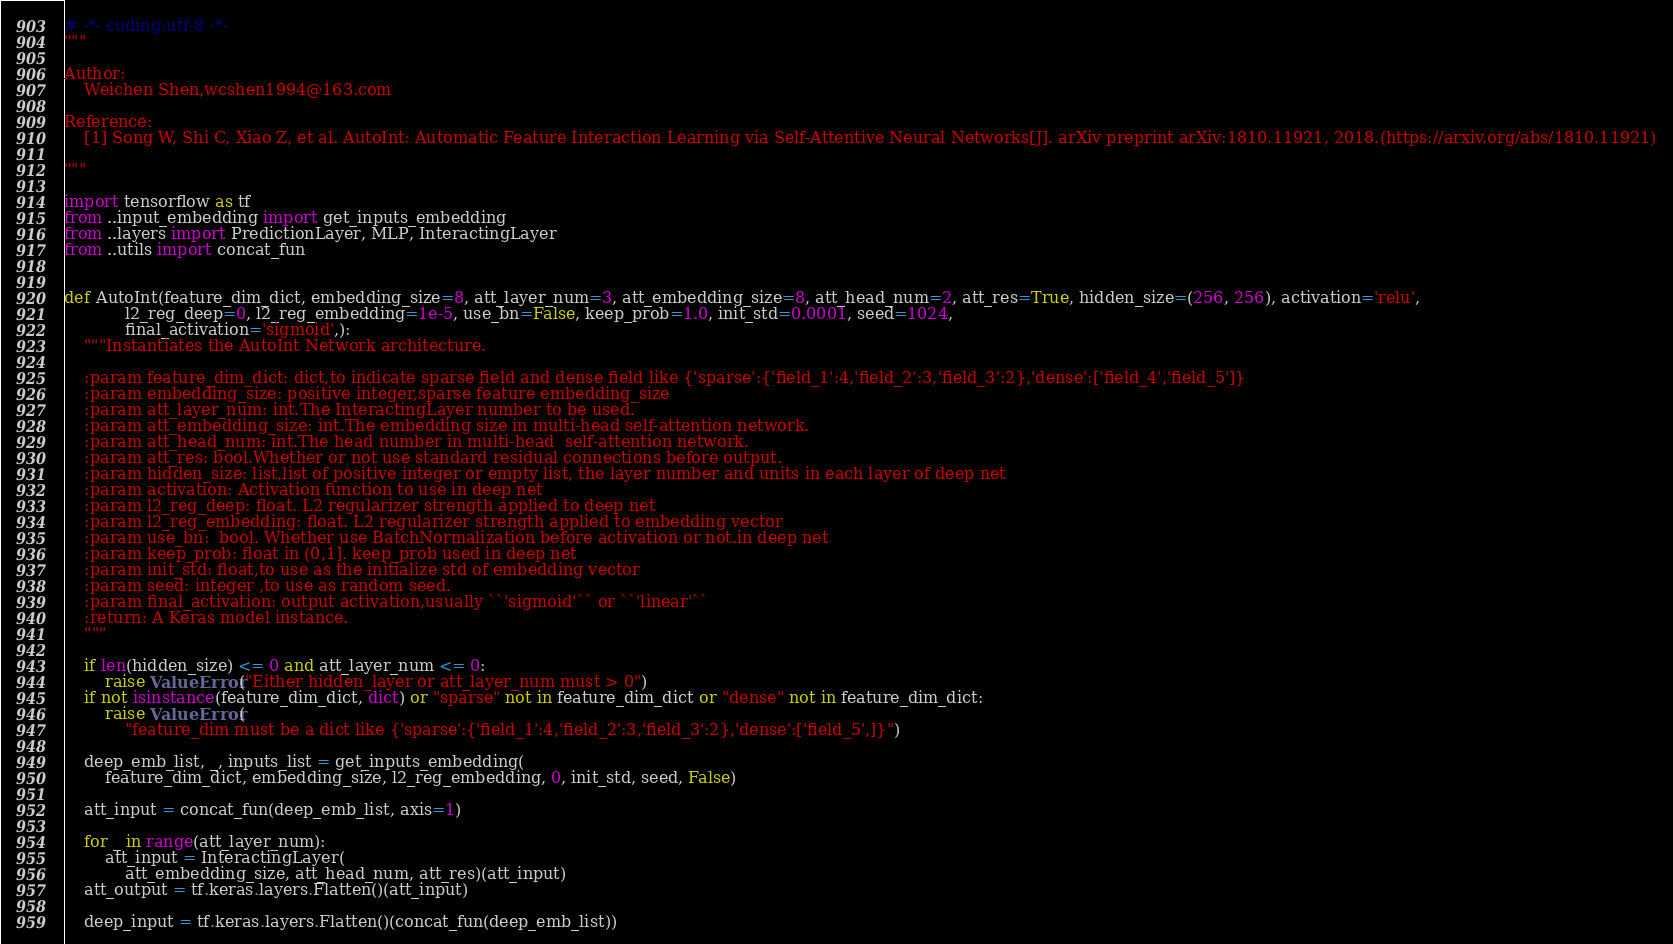Convert code to text. <code><loc_0><loc_0><loc_500><loc_500><_Python_># -*- coding:utf-8 -*-
"""

Author:
    Weichen Shen,wcshen1994@163.com

Reference:
    [1] Song W, Shi C, Xiao Z, et al. AutoInt: Automatic Feature Interaction Learning via Self-Attentive Neural Networks[J]. arXiv preprint arXiv:1810.11921, 2018.(https://arxiv.org/abs/1810.11921)

"""

import tensorflow as tf
from ..input_embedding import get_inputs_embedding
from ..layers import PredictionLayer, MLP, InteractingLayer
from ..utils import concat_fun


def AutoInt(feature_dim_dict, embedding_size=8, att_layer_num=3, att_embedding_size=8, att_head_num=2, att_res=True, hidden_size=(256, 256), activation='relu',
            l2_reg_deep=0, l2_reg_embedding=1e-5, use_bn=False, keep_prob=1.0, init_std=0.0001, seed=1024,
            final_activation='sigmoid',):
    """Instantiates the AutoInt Network architecture.

    :param feature_dim_dict: dict,to indicate sparse field and dense field like {'sparse':{'field_1':4,'field_2':3,'field_3':2},'dense':['field_4','field_5']}
    :param embedding_size: positive integer,sparse feature embedding_size
    :param att_layer_num: int.The InteractingLayer number to be used.
    :param att_embedding_size: int.The embedding size in multi-head self-attention network.
    :param att_head_num: int.The head number in multi-head  self-attention network.
    :param att_res: bool.Whether or not use standard residual connections before output.
    :param hidden_size: list,list of positive integer or empty list, the layer number and units in each layer of deep net
    :param activation: Activation function to use in deep net
    :param l2_reg_deep: float. L2 regularizer strength applied to deep net
    :param l2_reg_embedding: float. L2 regularizer strength applied to embedding vector
    :param use_bn:  bool. Whether use BatchNormalization before activation or not.in deep net
    :param keep_prob: float in (0,1]. keep_prob used in deep net
    :param init_std: float,to use as the initialize std of embedding vector
    :param seed: integer ,to use as random seed.
    :param final_activation: output activation,usually ``'sigmoid'`` or ``'linear'``
    :return: A Keras model instance.
    """

    if len(hidden_size) <= 0 and att_layer_num <= 0:
        raise ValueError("Either hidden_layer or att_layer_num must > 0")
    if not isinstance(feature_dim_dict, dict) or "sparse" not in feature_dim_dict or "dense" not in feature_dim_dict:
        raise ValueError(
            "feature_dim must be a dict like {'sparse':{'field_1':4,'field_2':3,'field_3':2},'dense':['field_5',]}")

    deep_emb_list, _, inputs_list = get_inputs_embedding(
        feature_dim_dict, embedding_size, l2_reg_embedding, 0, init_std, seed, False)

    att_input = concat_fun(deep_emb_list, axis=1)

    for _ in range(att_layer_num):
        att_input = InteractingLayer(
            att_embedding_size, att_head_num, att_res)(att_input)
    att_output = tf.keras.layers.Flatten()(att_input)

    deep_input = tf.keras.layers.Flatten()(concat_fun(deep_emb_list))
</code> 